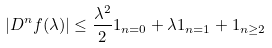<formula> <loc_0><loc_0><loc_500><loc_500>| D ^ { n } f ( \lambda ) | \leq \frac { \lambda ^ { 2 } } { 2 } 1 _ { n = 0 } + \lambda 1 _ { n = 1 } + 1 _ { n \geq 2 }</formula> 